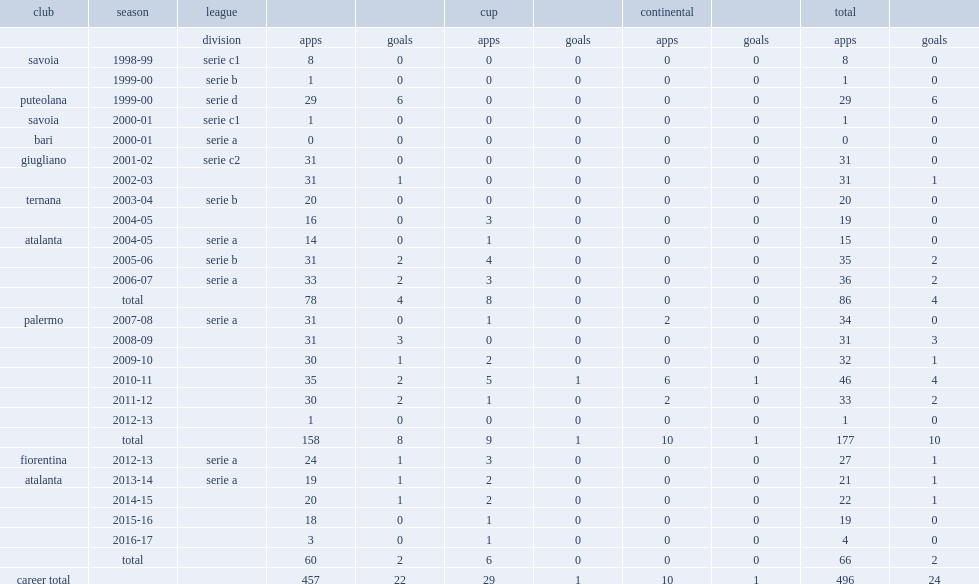Which league did migliaccio appear for bari in the 2000-01 season? Serie a. 